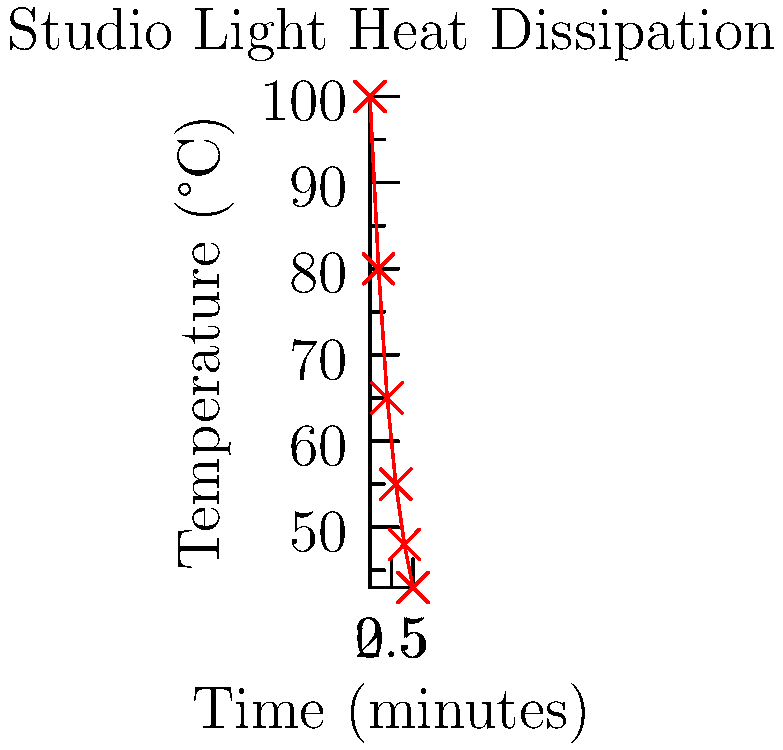As a movie star familiar with on-set equipment, you're curious about the heat dissipation in a high-powered studio light. The graph shows the temperature decrease of a studio light after it's turned off. If the initial temperature is 100°C and the ambient temperature is 25°C, what is the approximate cooling time constant $\tau$ in minutes? To find the cooling time constant $\tau$, we can use the equation for exponential cooling:

$T(t) = T_{ambient} + (T_{initial} - T_{ambient}) \cdot e^{-t/\tau}$

Where:
- $T(t)$ is the temperature at time $t$
- $T_{ambient}$ is the ambient temperature (25°C)
- $T_{initial}$ is the initial temperature (100°C)
- $t$ is the time
- $\tau$ is the time constant we're looking for

We know that after one time constant, the temperature difference should be reduced to about 37% of its initial value. So we need to find the time when:

$T(\tau) = 25 + (100 - 25) \cdot e^{-1} \approx 25 + 75 \cdot 0.368 \approx 52.6°C$

Looking at the graph, we can see that the temperature reaches approximately 52.6°C between 3 and 4 minutes.

By interpolation, we can estimate that this occurs closer to 3 minutes.

Therefore, the approximate cooling time constant $\tau$ is 3 minutes.
Answer: 3 minutes 